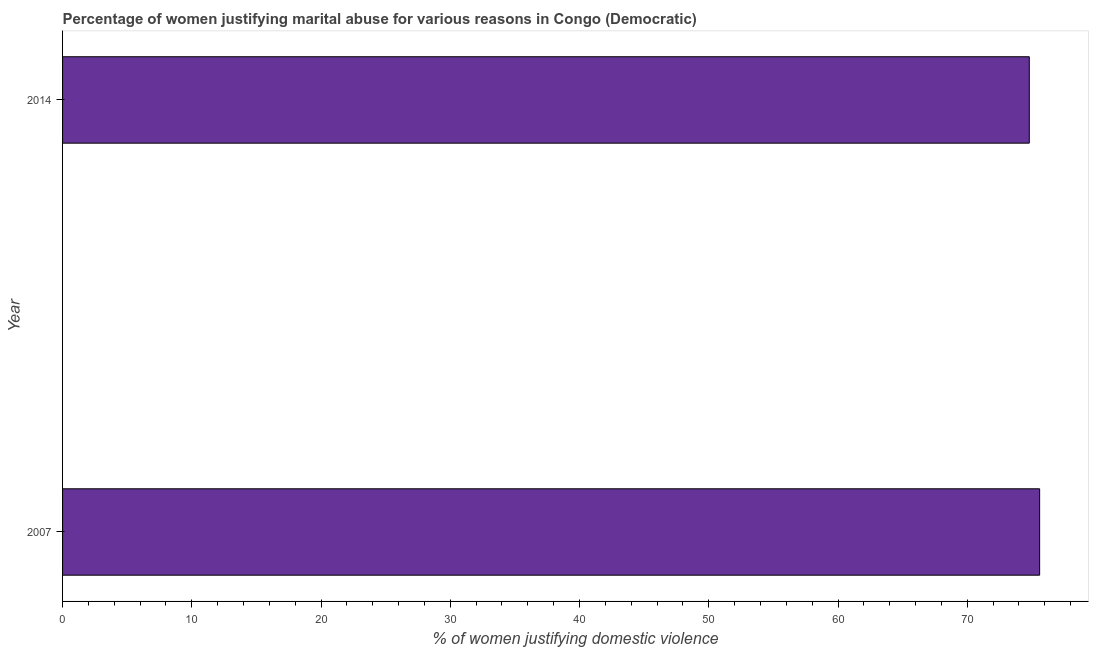Does the graph contain grids?
Make the answer very short. No. What is the title of the graph?
Offer a terse response. Percentage of women justifying marital abuse for various reasons in Congo (Democratic). What is the label or title of the X-axis?
Your answer should be very brief. % of women justifying domestic violence. What is the label or title of the Y-axis?
Offer a terse response. Year. What is the percentage of women justifying marital abuse in 2014?
Keep it short and to the point. 74.8. Across all years, what is the maximum percentage of women justifying marital abuse?
Give a very brief answer. 75.6. Across all years, what is the minimum percentage of women justifying marital abuse?
Your response must be concise. 74.8. In which year was the percentage of women justifying marital abuse maximum?
Give a very brief answer. 2007. In which year was the percentage of women justifying marital abuse minimum?
Keep it short and to the point. 2014. What is the sum of the percentage of women justifying marital abuse?
Offer a terse response. 150.4. What is the average percentage of women justifying marital abuse per year?
Provide a succinct answer. 75.2. What is the median percentage of women justifying marital abuse?
Give a very brief answer. 75.2. What is the ratio of the percentage of women justifying marital abuse in 2007 to that in 2014?
Offer a very short reply. 1.01. In how many years, is the percentage of women justifying marital abuse greater than the average percentage of women justifying marital abuse taken over all years?
Ensure brevity in your answer.  1. How many bars are there?
Your answer should be very brief. 2. What is the difference between two consecutive major ticks on the X-axis?
Your answer should be compact. 10. Are the values on the major ticks of X-axis written in scientific E-notation?
Your response must be concise. No. What is the % of women justifying domestic violence of 2007?
Offer a terse response. 75.6. What is the % of women justifying domestic violence of 2014?
Offer a very short reply. 74.8. What is the difference between the % of women justifying domestic violence in 2007 and 2014?
Give a very brief answer. 0.8. 